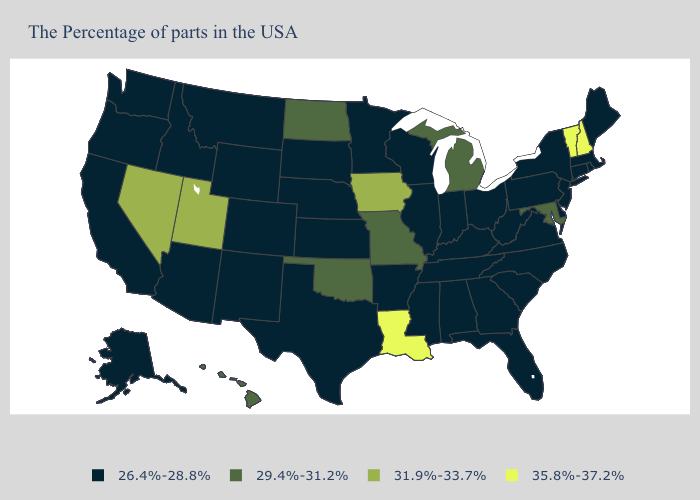What is the highest value in the USA?
Keep it brief. 35.8%-37.2%. Name the states that have a value in the range 31.9%-33.7%?
Quick response, please. Iowa, Utah, Nevada. Which states have the lowest value in the South?
Answer briefly. Delaware, Virginia, North Carolina, South Carolina, West Virginia, Florida, Georgia, Kentucky, Alabama, Tennessee, Mississippi, Arkansas, Texas. Does the first symbol in the legend represent the smallest category?
Answer briefly. Yes. How many symbols are there in the legend?
Quick response, please. 4. What is the highest value in the South ?
Give a very brief answer. 35.8%-37.2%. Name the states that have a value in the range 29.4%-31.2%?
Quick response, please. Maryland, Michigan, Missouri, Oklahoma, North Dakota, Hawaii. Which states have the highest value in the USA?
Answer briefly. New Hampshire, Vermont, Louisiana. Which states hav the highest value in the South?
Keep it brief. Louisiana. Does the map have missing data?
Keep it brief. No. Name the states that have a value in the range 31.9%-33.7%?
Short answer required. Iowa, Utah, Nevada. What is the value of Oklahoma?
Concise answer only. 29.4%-31.2%. Does New Hampshire have the lowest value in the Northeast?
Write a very short answer. No. Does North Dakota have the lowest value in the USA?
Answer briefly. No. Name the states that have a value in the range 29.4%-31.2%?
Write a very short answer. Maryland, Michigan, Missouri, Oklahoma, North Dakota, Hawaii. 